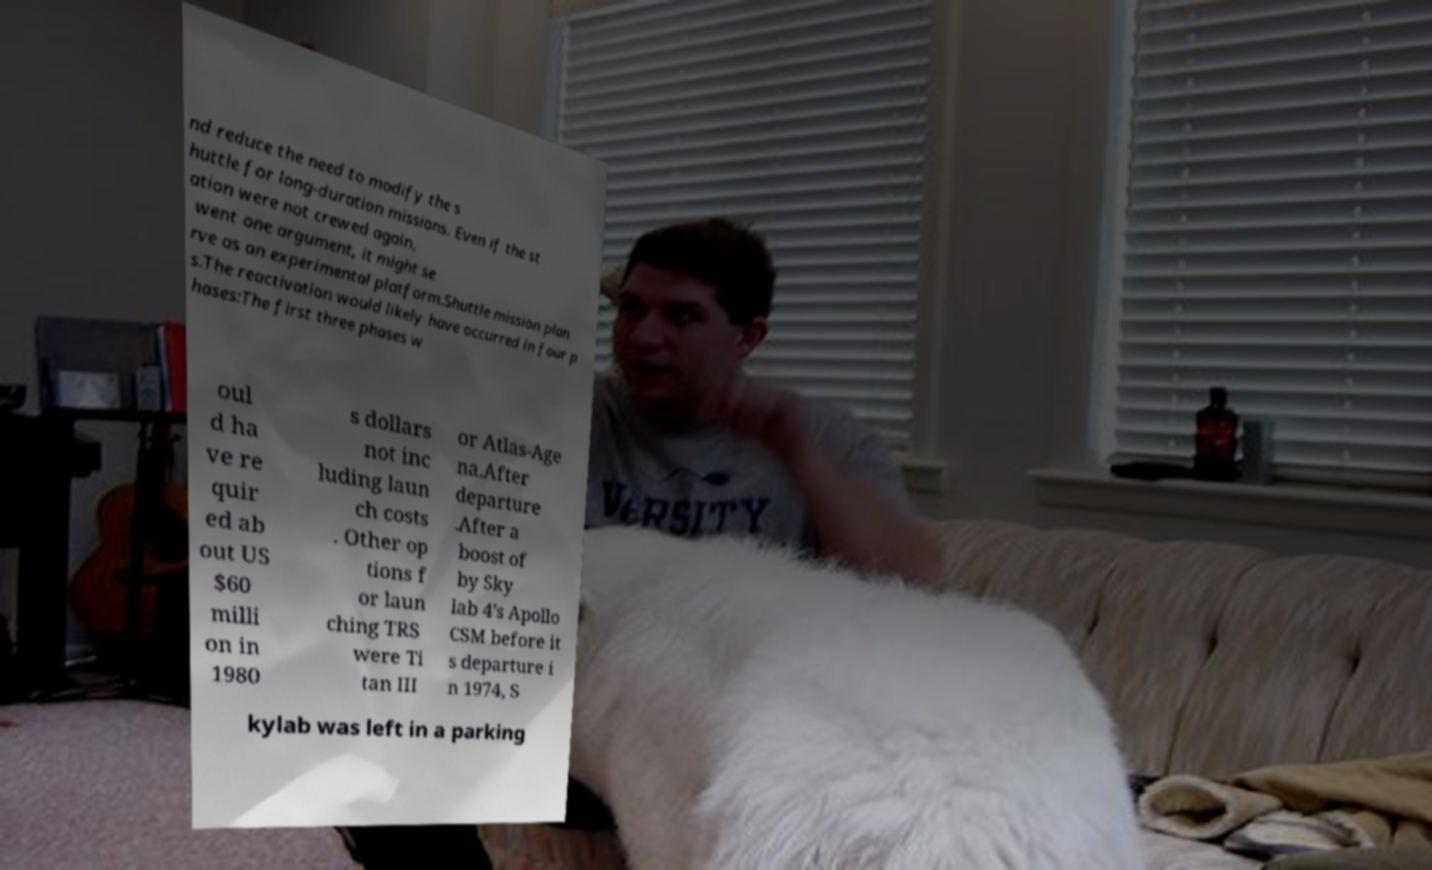Could you extract and type out the text from this image? nd reduce the need to modify the s huttle for long-duration missions. Even if the st ation were not crewed again, went one argument, it might se rve as an experimental platform.Shuttle mission plan s.The reactivation would likely have occurred in four p hases:The first three phases w oul d ha ve re quir ed ab out US $60 milli on in 1980 s dollars not inc luding laun ch costs . Other op tions f or laun ching TRS were Ti tan III or Atlas-Age na.After departure .After a boost of by Sky lab 4's Apollo CSM before it s departure i n 1974, S kylab was left in a parking 